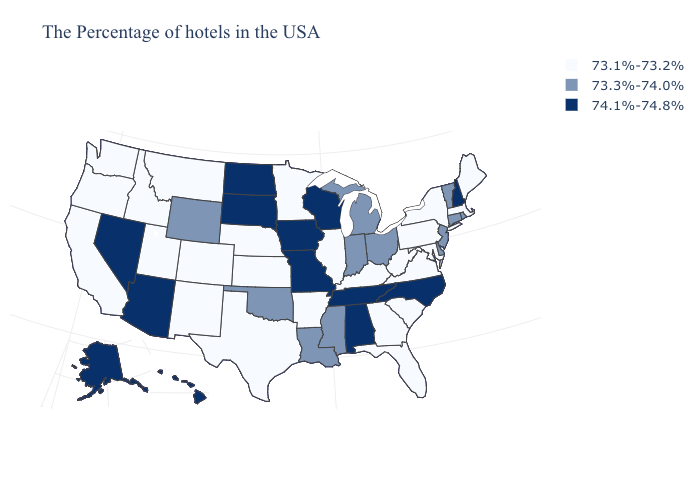Which states hav the highest value in the West?
Short answer required. Arizona, Nevada, Alaska, Hawaii. What is the value of California?
Be succinct. 73.1%-73.2%. Name the states that have a value in the range 74.1%-74.8%?
Write a very short answer. New Hampshire, North Carolina, Alabama, Tennessee, Wisconsin, Missouri, Iowa, South Dakota, North Dakota, Arizona, Nevada, Alaska, Hawaii. What is the highest value in the MidWest ?
Concise answer only. 74.1%-74.8%. What is the value of Alabama?
Concise answer only. 74.1%-74.8%. What is the lowest value in the USA?
Write a very short answer. 73.1%-73.2%. Does Texas have the lowest value in the South?
Quick response, please. Yes. What is the highest value in the USA?
Write a very short answer. 74.1%-74.8%. What is the value of Ohio?
Write a very short answer. 73.3%-74.0%. Name the states that have a value in the range 73.1%-73.2%?
Give a very brief answer. Maine, Massachusetts, New York, Maryland, Pennsylvania, Virginia, South Carolina, West Virginia, Florida, Georgia, Kentucky, Illinois, Arkansas, Minnesota, Kansas, Nebraska, Texas, Colorado, New Mexico, Utah, Montana, Idaho, California, Washington, Oregon. How many symbols are there in the legend?
Be succinct. 3. Among the states that border Alabama , does Mississippi have the lowest value?
Quick response, please. No. Does Oklahoma have the lowest value in the USA?
Answer briefly. No. What is the value of Oklahoma?
Keep it brief. 73.3%-74.0%. Name the states that have a value in the range 73.3%-74.0%?
Keep it brief. Rhode Island, Vermont, Connecticut, New Jersey, Delaware, Ohio, Michigan, Indiana, Mississippi, Louisiana, Oklahoma, Wyoming. 